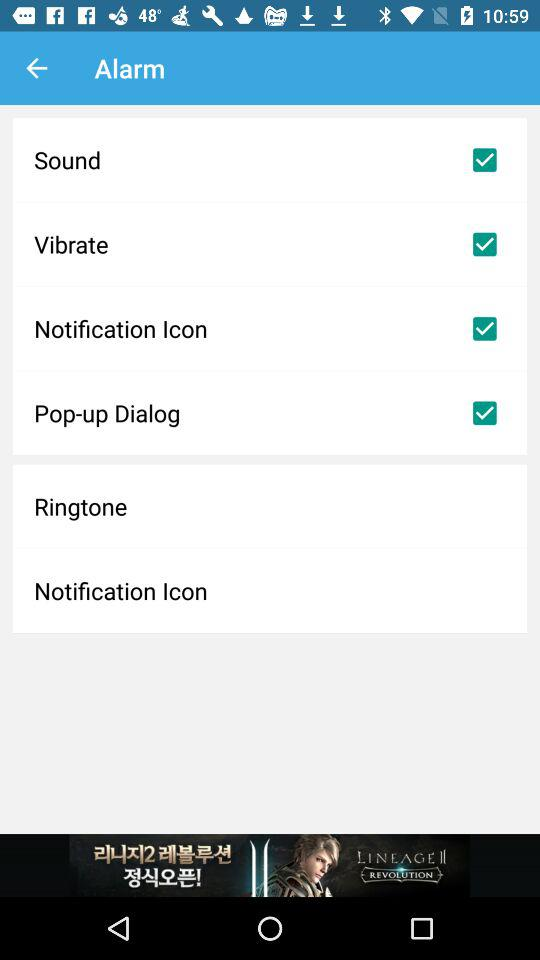What is the status of "Vibrate"? The status is "on". 